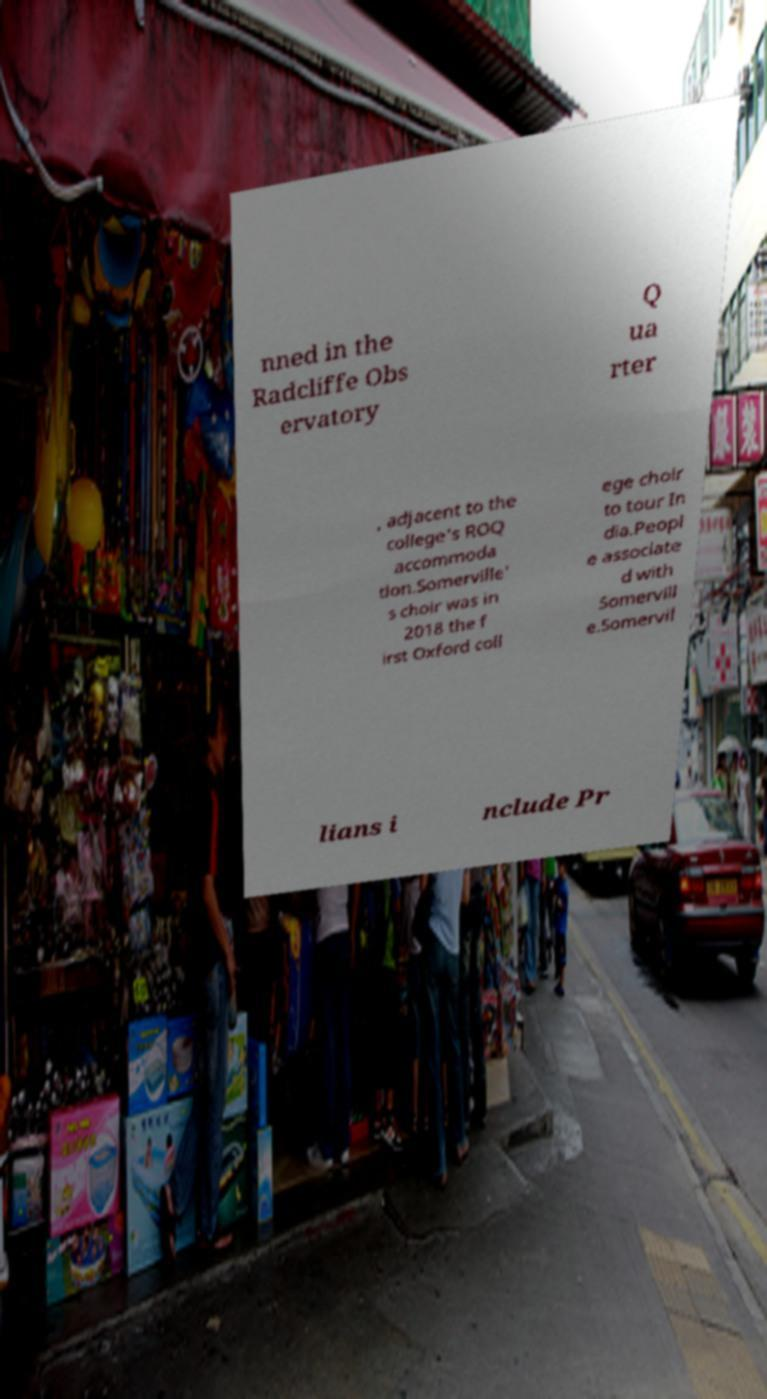Please identify and transcribe the text found in this image. nned in the Radcliffe Obs ervatory Q ua rter , adjacent to the college's ROQ accommoda tion.Somerville' s choir was in 2018 the f irst Oxford coll ege choir to tour In dia.Peopl e associate d with Somervill e.Somervil lians i nclude Pr 